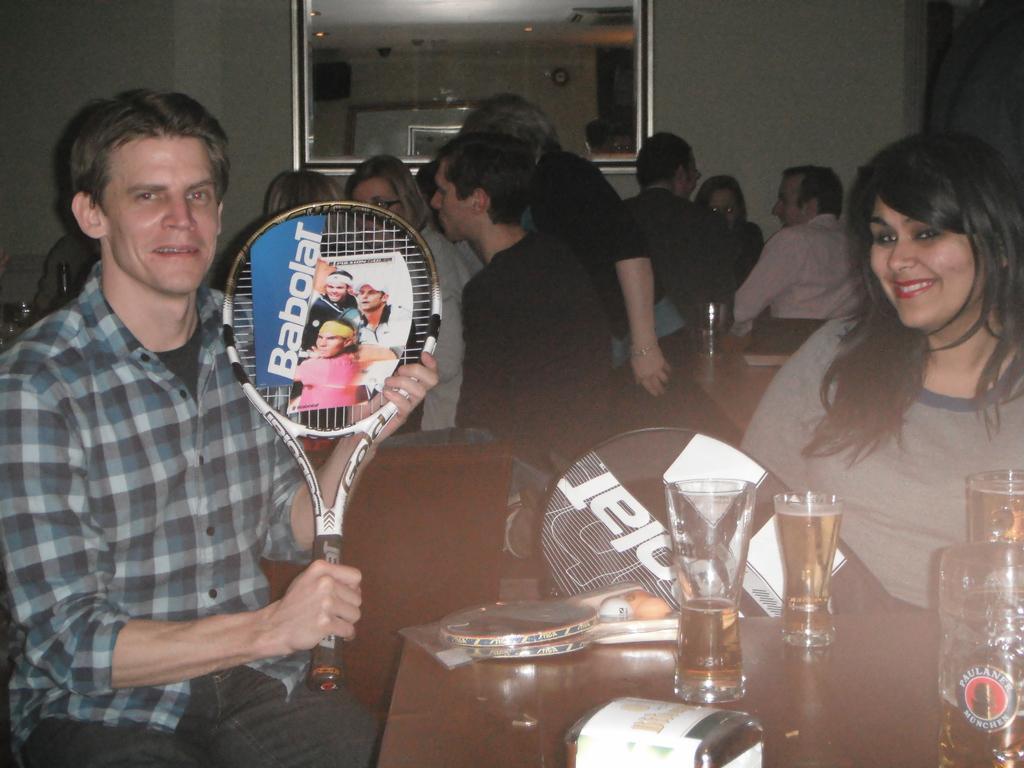In one or two sentences, can you explain what this image depicts? In this image there are group of people sitting on the chair. On the table there is a glass and the man is holding a racket. 